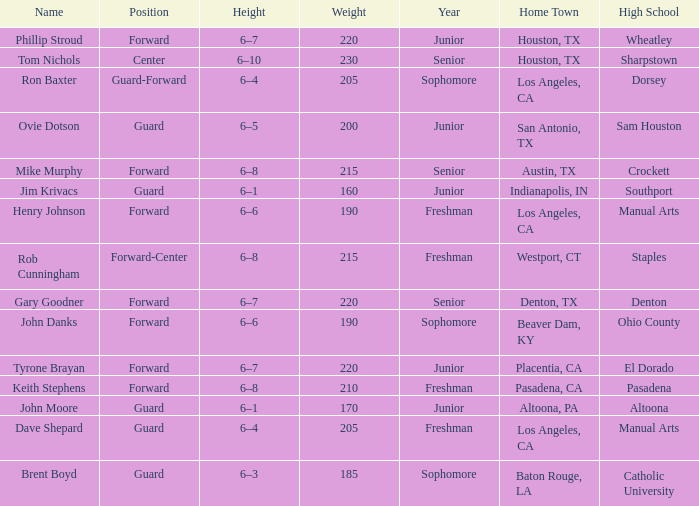What is the Position with a Year with freshman, and a Weight larger than 210? Forward-Center. 